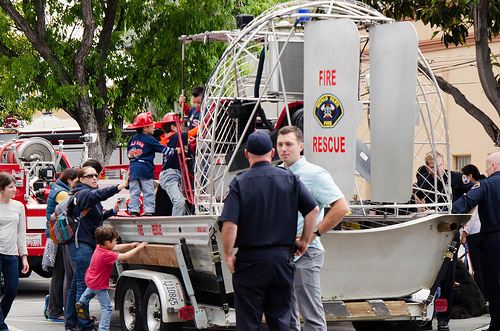<image>
Is there a backpack on the boy? No. The backpack is not positioned on the boy. They may be near each other, but the backpack is not supported by or resting on top of the boy. Is the fire truck behind the little kid? Yes. From this viewpoint, the fire truck is positioned behind the little kid, with the little kid partially or fully occluding the fire truck. 